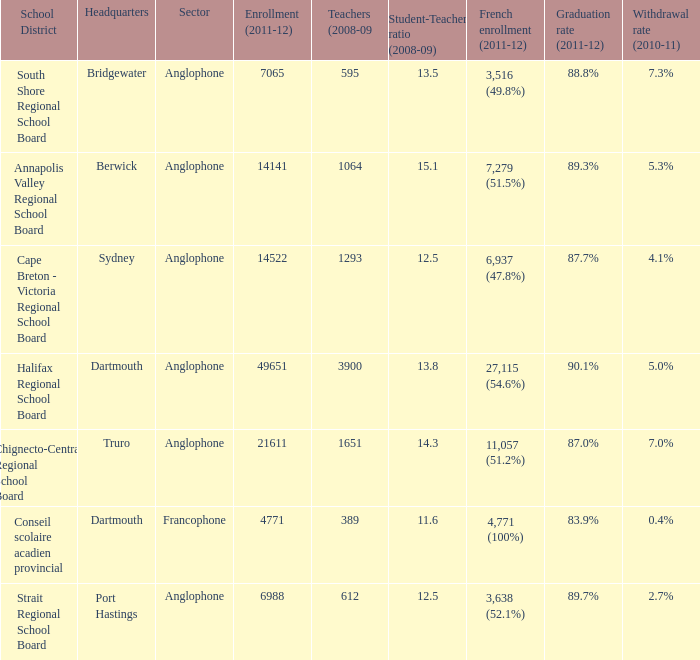What is the graduation rate for the school district with headquarters located in Sydney? 87.7%. 